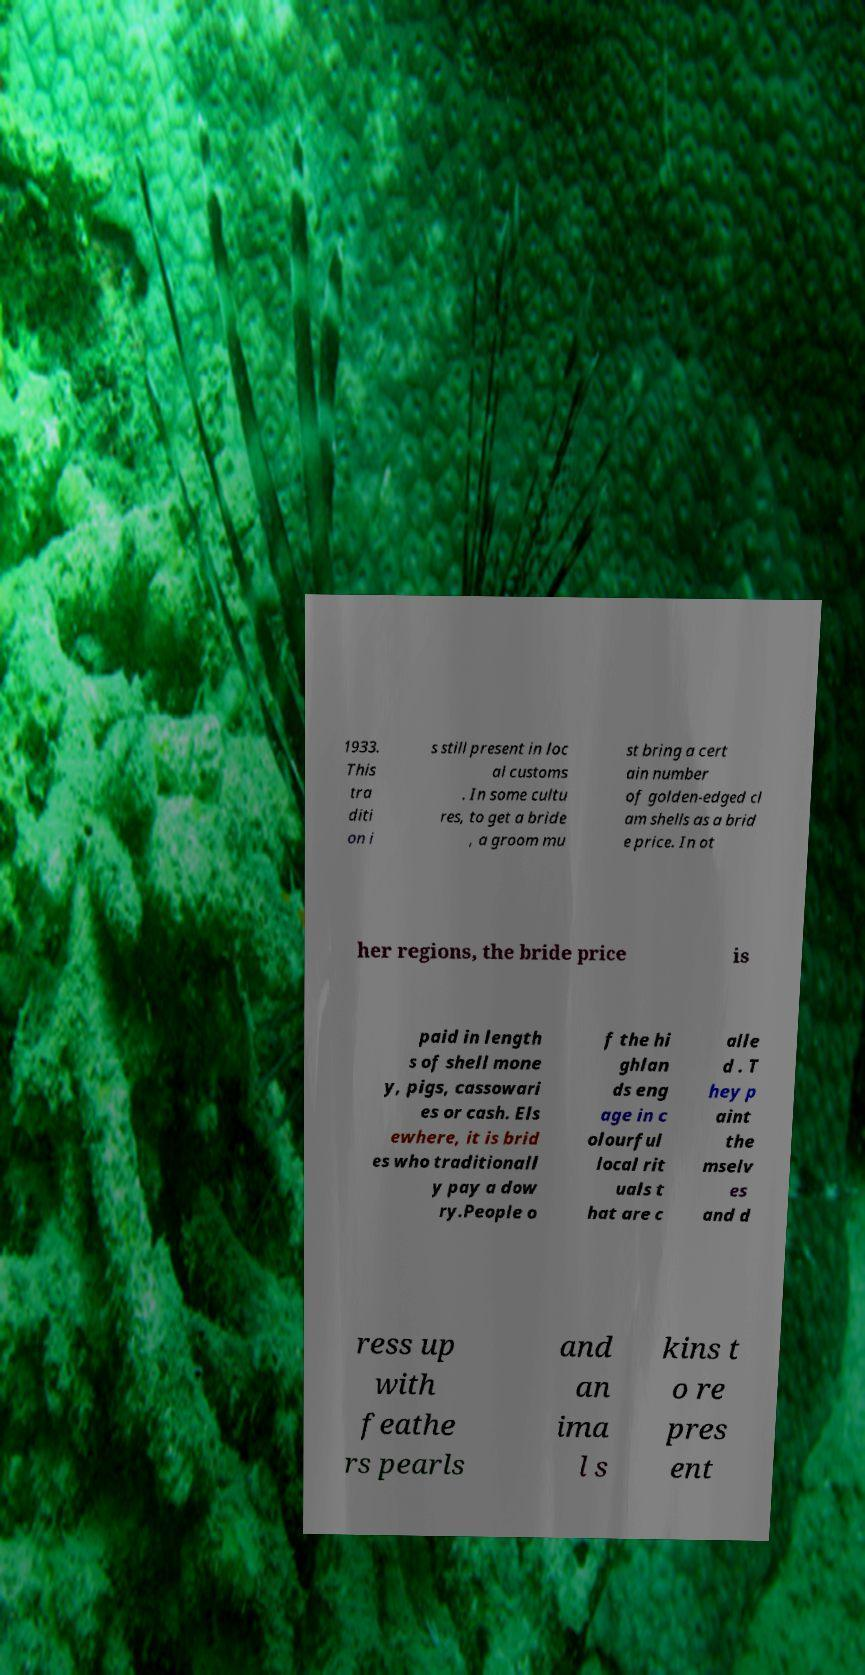Can you read and provide the text displayed in the image?This photo seems to have some interesting text. Can you extract and type it out for me? 1933. This tra diti on i s still present in loc al customs . In some cultu res, to get a bride , a groom mu st bring a cert ain number of golden-edged cl am shells as a brid e price. In ot her regions, the bride price is paid in length s of shell mone y, pigs, cassowari es or cash. Els ewhere, it is brid es who traditionall y pay a dow ry.People o f the hi ghlan ds eng age in c olourful local rit uals t hat are c alle d . T hey p aint the mselv es and d ress up with feathe rs pearls and an ima l s kins t o re pres ent 